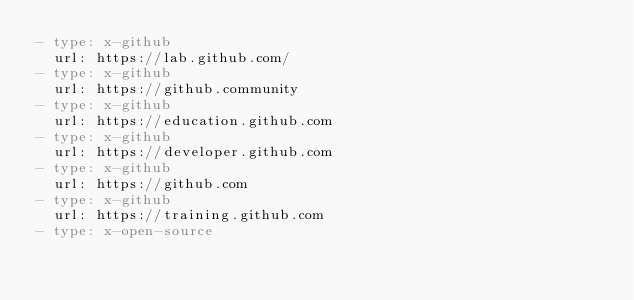<code> <loc_0><loc_0><loc_500><loc_500><_YAML_>- type: x-github
  url: https://lab.github.com/
- type: x-github
  url: https://github.community
- type: x-github
  url: https://education.github.com
- type: x-github
  url: https://developer.github.com
- type: x-github
  url: https://github.com
- type: x-github
  url: https://training.github.com
- type: x-open-source</code> 